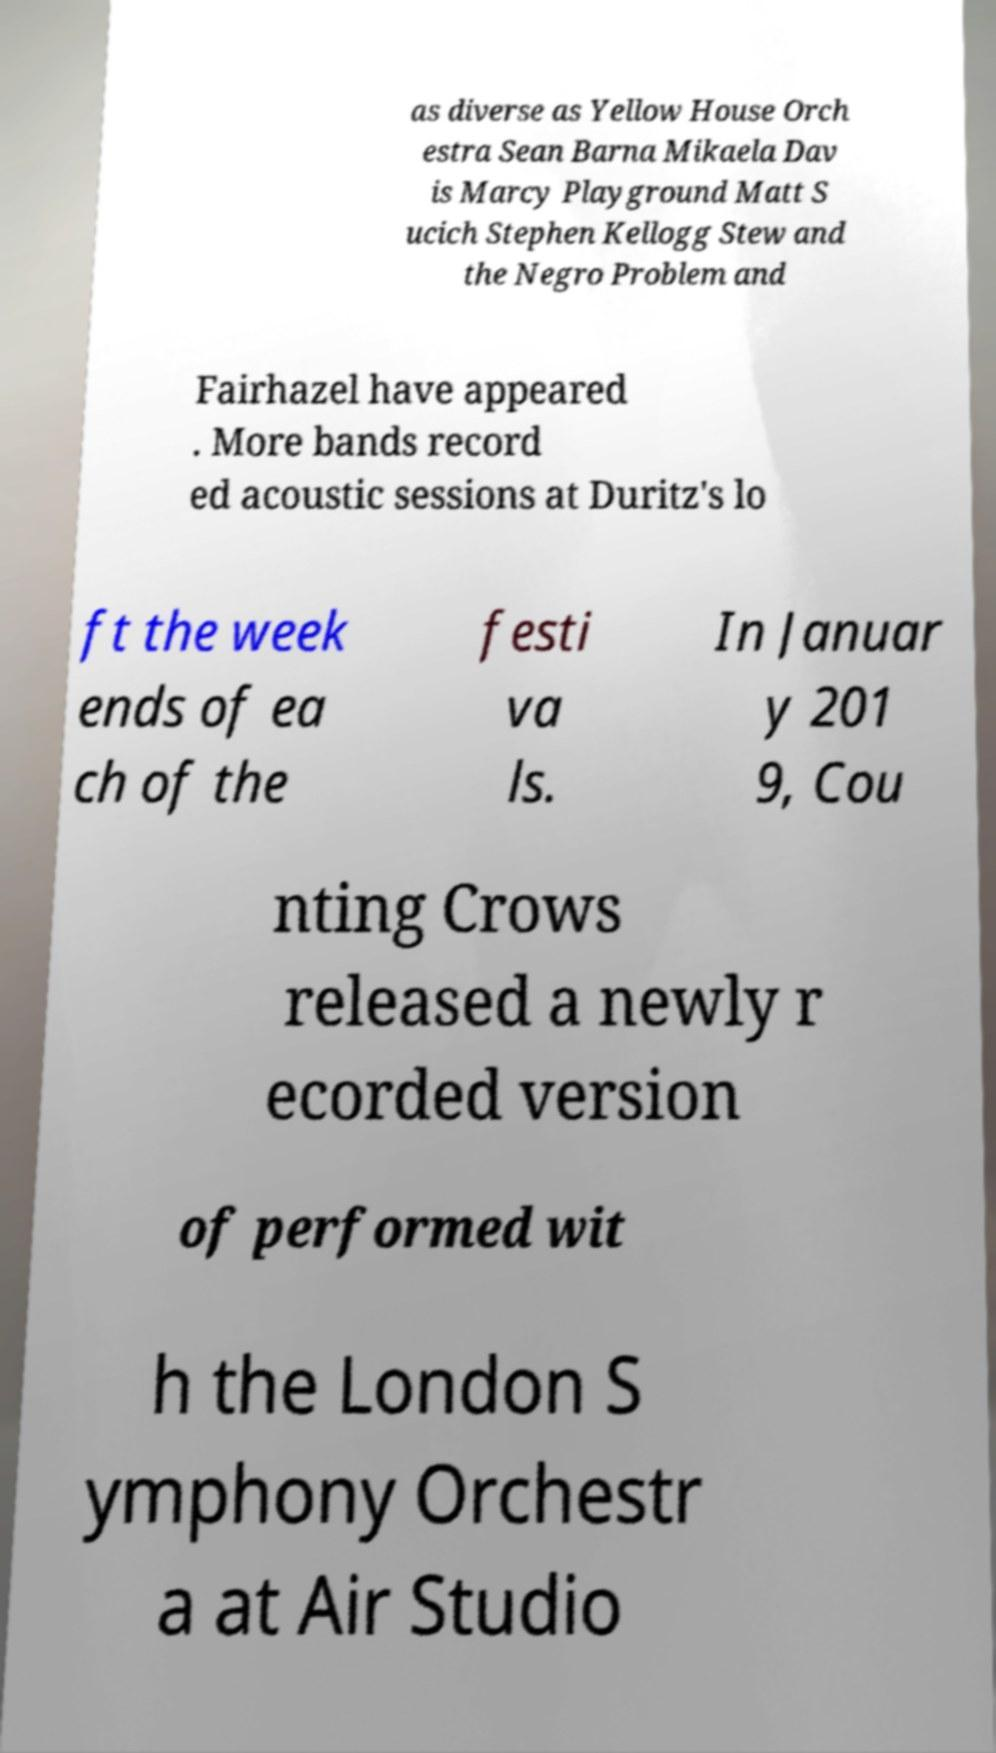Please identify and transcribe the text found in this image. as diverse as Yellow House Orch estra Sean Barna Mikaela Dav is Marcy Playground Matt S ucich Stephen Kellogg Stew and the Negro Problem and Fairhazel have appeared . More bands record ed acoustic sessions at Duritz's lo ft the week ends of ea ch of the festi va ls. In Januar y 201 9, Cou nting Crows released a newly r ecorded version of performed wit h the London S ymphony Orchestr a at Air Studio 